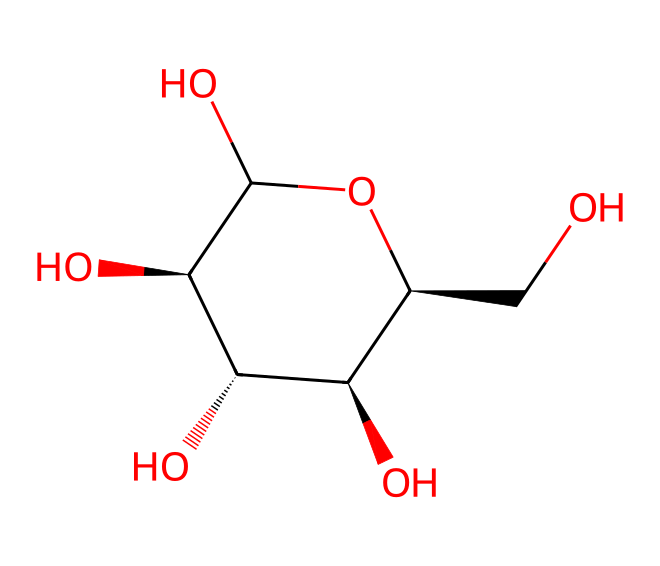What is the molecular formula for cellulose based on the structure? The SMILES representation indicates a structure comprising a certain number of carbon, hydrogen, and oxygen atoms. By counting: there are 6 carbon atoms, 10 hydrogen atoms, and 5 oxygen atoms in the structure. Therefore, the molecular formula is C6H10O5.
Answer: C6H10O5 How many rings are present in the cellulose molecule? Analyzing the SMILES structure, there is only one ring structure indicated by the notation "C1", suggesting a single cyclic arrangement of carbon atoms. This can be observed as the atoms are indicated in a loop.
Answer: 1 What is the primary functional group present in cellulose? In cellulose, the presence of multiple hydroxyl (-OH) groups confirms that the primary functional group is hydroxyl. This is evidenced by the oxygen atoms connected through single bonds to hydrogen atoms.
Answer: hydroxyl What does the stereochemistry of glucose derivatives tell us about cellulose's structure? The presence of stereo centers (indicated by @ symbols) in carbon atoms suggests that cellulose has specific spatial orientations, leading to its structural properties as a polysaccharide and its digestibility profile. Understanding the stereochemistry is crucial for its role in biological functions.
Answer: specific spatial orientations How many hydroxyl groups are present in the cellulose molecule? From the structure, we can identify that there are a total of 3 hydroxyl (-OH) groups on the glucose unit that constitute the cellulose polymer. Each hydroxyl is indicated by a corresponding oxygen and hydrogen pair clearly shown in the SMILES notation.
Answer: 3 Is cellulose a simple sugar or a complex carbohydrate? The molecular structure shows multiple sugar units linked through glycosidic bonds, classifying cellulose as a complex carbohydrate rather than a simple sugar, which is characterized by individual sugar units.
Answer: complex carbohydrate 